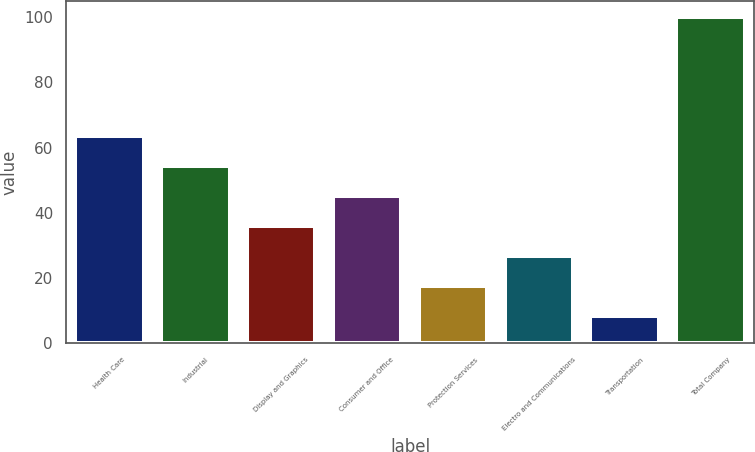Convert chart. <chart><loc_0><loc_0><loc_500><loc_500><bar_chart><fcel>Health Care<fcel>Industrial<fcel>Display and Graphics<fcel>Consumer and Office<fcel>Protection Services<fcel>Electro and Communications<fcel>Transportation<fcel>Total Company<nl><fcel>63.4<fcel>54.25<fcel>35.95<fcel>45.1<fcel>17.65<fcel>26.8<fcel>8.5<fcel>100<nl></chart> 